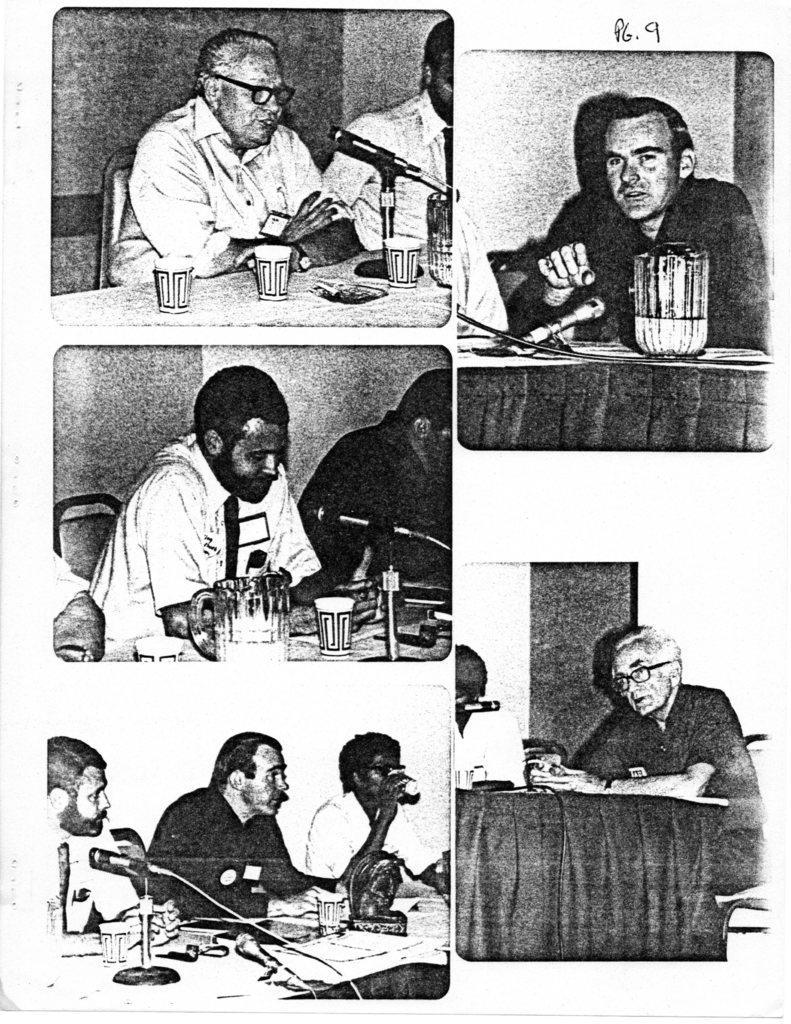In one or two sentences, can you explain what this image depicts? In the image we can see the image is collage of five pictures and there are people sitting on chair and on table there is mic with stand. There are jug and glasses are kept on the table and the image is in black and white colour. 